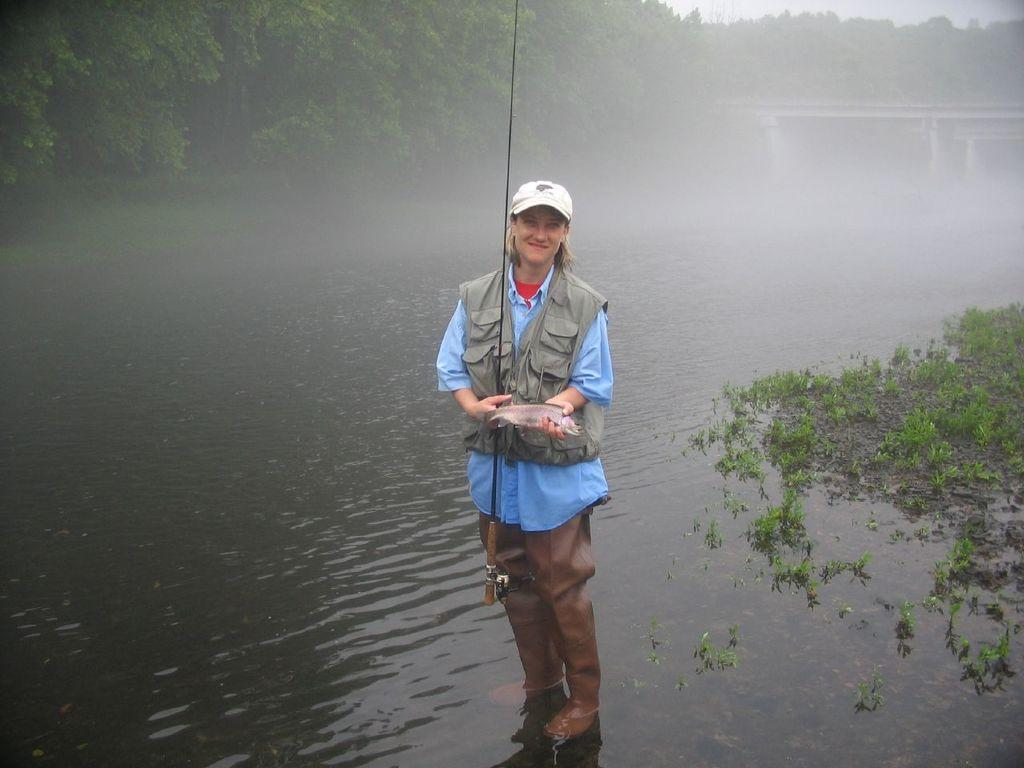What is the woman in the image holding? The woman is holding a stick and a fish in the image. What is the woman standing on or near in the image? There is water visible in the image, which suggests the woman might be standing near or in the water. What type of vegetation is present in the image? There is grass in the image, and trees are visible in the background. What part of the natural environment is visible in the image? The sky is visible in the background of the image. What time is displayed on the clock in the image? There is no clock present in the image. Can you describe the behavior of the deer in the image? There are no deer present in the image. 